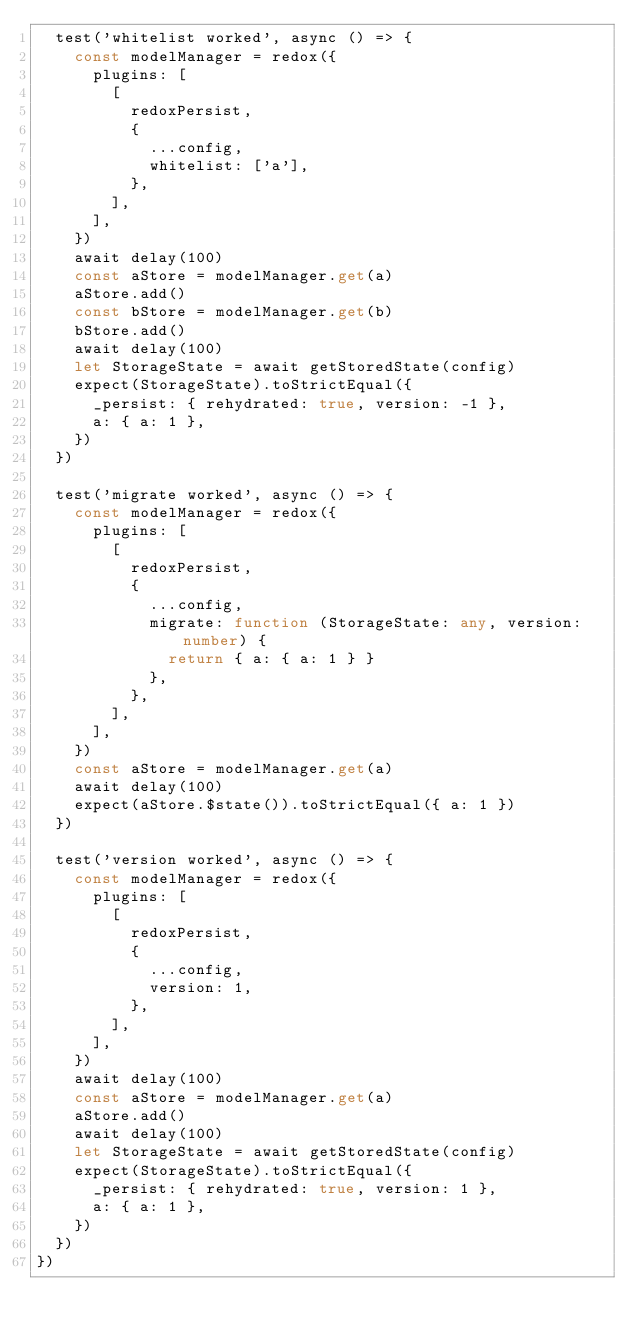<code> <loc_0><loc_0><loc_500><loc_500><_TypeScript_>	test('whitelist worked', async () => {
		const modelManager = redox({
			plugins: [
				[
					redoxPersist,
					{
						...config,
						whitelist: ['a'],
					},
				],
			],
		})
		await delay(100)
		const aStore = modelManager.get(a)
		aStore.add()
		const bStore = modelManager.get(b)
		bStore.add()
		await delay(100)
		let StorageState = await getStoredState(config)
		expect(StorageState).toStrictEqual({
			_persist: { rehydrated: true, version: -1 },
			a: { a: 1 },
		})
	})

	test('migrate worked', async () => {
		const modelManager = redox({
			plugins: [
				[
					redoxPersist,
					{
						...config,
						migrate: function (StorageState: any, version: number) {
							return { a: { a: 1 } }
						},
					},
				],
			],
		})
		const aStore = modelManager.get(a)
		await delay(100)
		expect(aStore.$state()).toStrictEqual({ a: 1 })
	})

	test('version worked', async () => {
		const modelManager = redox({
			plugins: [
				[
					redoxPersist,
					{
						...config,
						version: 1,
					},
				],
			],
		})
		await delay(100)
		const aStore = modelManager.get(a)
		aStore.add()
		await delay(100)
		let StorageState = await getStoredState(config)
		expect(StorageState).toStrictEqual({
			_persist: { rehydrated: true, version: 1 },
			a: { a: 1 },
		})
	})
})
</code> 